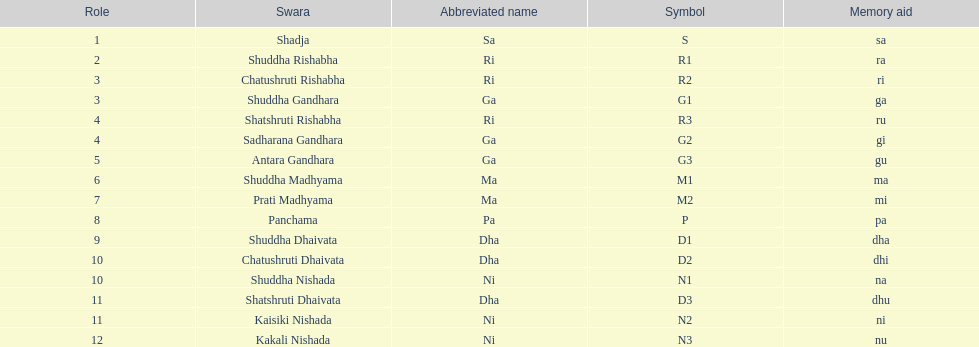How many swaras do not have dhaivata in their name? 13. 